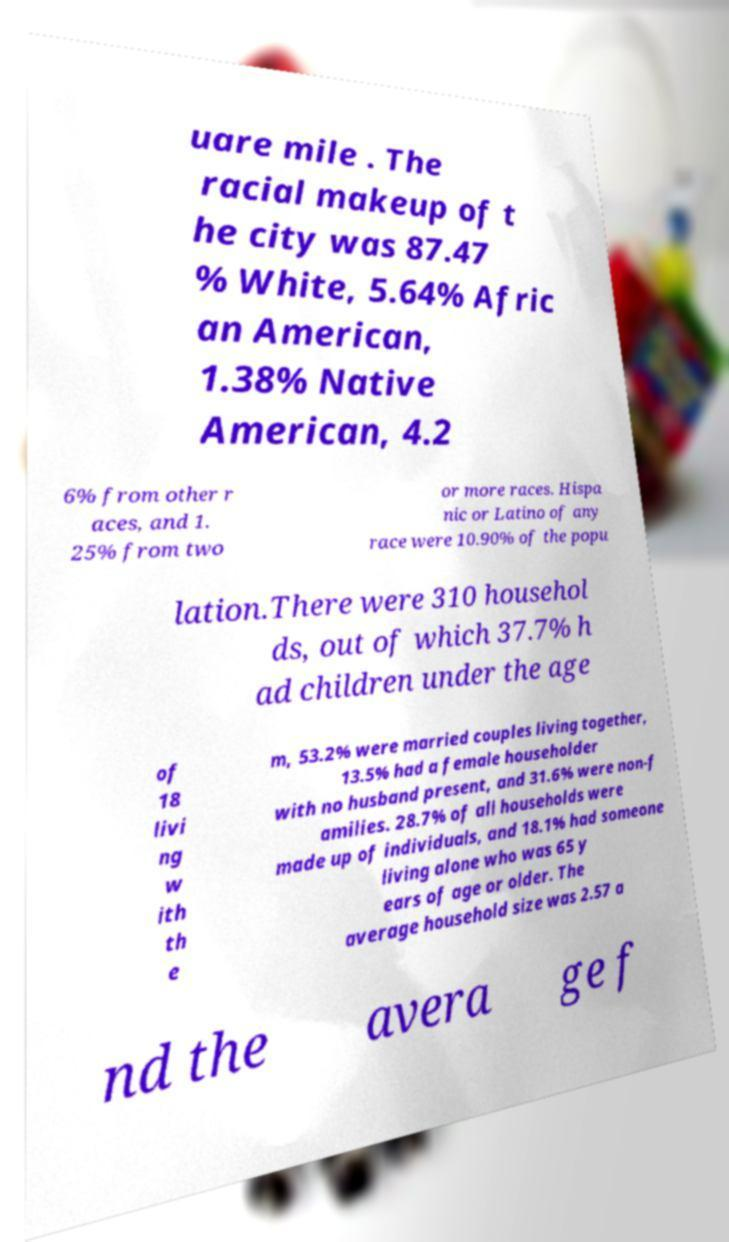I need the written content from this picture converted into text. Can you do that? uare mile . The racial makeup of t he city was 87.47 % White, 5.64% Afric an American, 1.38% Native American, 4.2 6% from other r aces, and 1. 25% from two or more races. Hispa nic or Latino of any race were 10.90% of the popu lation.There were 310 househol ds, out of which 37.7% h ad children under the age of 18 livi ng w ith th e m, 53.2% were married couples living together, 13.5% had a female householder with no husband present, and 31.6% were non-f amilies. 28.7% of all households were made up of individuals, and 18.1% had someone living alone who was 65 y ears of age or older. The average household size was 2.57 a nd the avera ge f 